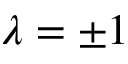<formula> <loc_0><loc_0><loc_500><loc_500>\lambda = \pm 1</formula> 